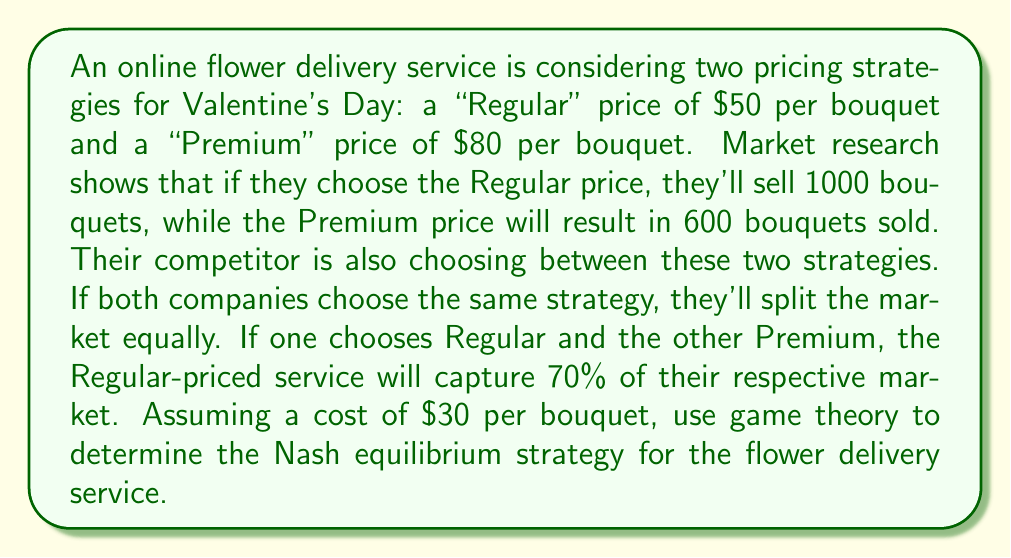Can you answer this question? Let's approach this step-by-step using game theory:

1) First, we need to calculate the payoffs for each strategy combination:

   a) Both choose Regular:
      Profit = (Price - Cost) * (Sales / 2)
      $$ (50 - 30) * (1000 / 2) = 20 * 500 = $10,000 $$

   b) Both choose Premium:
      $$ (80 - 30) * (600 / 2) = 50 * 300 = $15,000 $$

   c) Our service Regular, competitor Premium:
      $$ (50 - 30) * (1000 * 0.7) = 20 * 700 = $14,000 $$

   d) Our service Premium, competitor Regular:
      $$ (80 - 30) * (600 * 0.3) = 50 * 180 = $9,000 $$

2) Now we can construct the payoff matrix:

   $$
   \begin{array}{c|c|c}
    & \text{Competitor Regular} & \text{Competitor Premium} \\
   \hline
   \text{Our Regular} & (10000, 10000) & (14000, 9000) \\
   \hline
   \text{Our Premium} & (9000, 14000) & (15000, 15000)
   \end{array}
   $$

3) To find the Nash equilibrium, we need to identify strategies where neither player has an incentive to unilaterally change their strategy.

4) If the competitor chooses Regular:
   - Our best response is Regular ($10,000 > $9,000)

5) If the competitor chooses Premium:
   - Our best response is Premium ($15,000 > $14,000)

6) The same logic applies to the competitor's decisions.

7) We can see that there are two Nash equilibria:
   - Both choose Regular
   - Both choose Premium

8) However, the Premium strategy dominates the Regular strategy for both players, as it always yields a higher payoff regardless of the other player's choice.

Therefore, the Nash equilibrium strategy for the flower delivery service is to choose the Premium pricing of $80 per bouquet.
Answer: Choose Premium pricing ($80 per bouquet) 